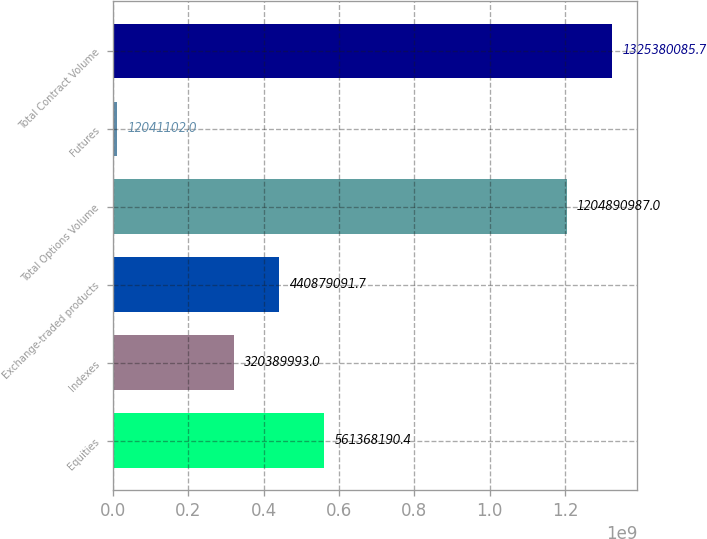Convert chart to OTSL. <chart><loc_0><loc_0><loc_500><loc_500><bar_chart><fcel>Equities<fcel>Indexes<fcel>Exchange-traded products<fcel>Total Options Volume<fcel>Futures<fcel>Total Contract Volume<nl><fcel>5.61368e+08<fcel>3.2039e+08<fcel>4.40879e+08<fcel>1.20489e+09<fcel>1.20411e+07<fcel>1.32538e+09<nl></chart> 